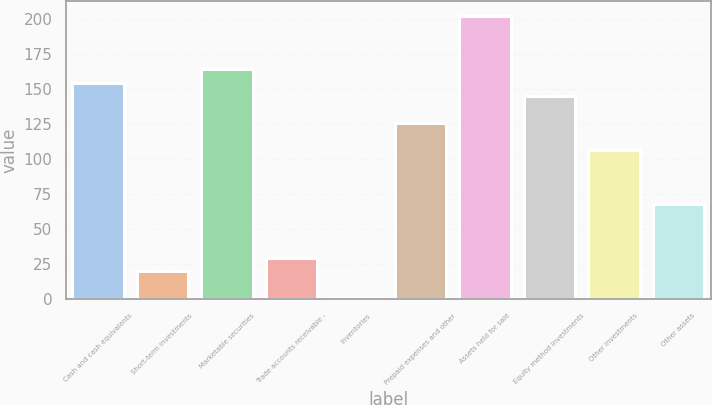Convert chart to OTSL. <chart><loc_0><loc_0><loc_500><loc_500><bar_chart><fcel>Cash and cash equivalents<fcel>Short-term investments<fcel>Marketable securities<fcel>Trade accounts receivable -<fcel>Inventories<fcel>Prepaid expenses and other<fcel>Assets held for sale<fcel>Equity method investments<fcel>Other investments<fcel>Other assets<nl><fcel>154.6<fcel>20.2<fcel>164.2<fcel>29.8<fcel>1<fcel>125.8<fcel>202.6<fcel>145<fcel>106.6<fcel>68.2<nl></chart> 